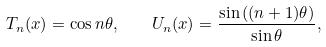<formula> <loc_0><loc_0><loc_500><loc_500>T _ { n } ( x ) = \cos n \theta , \quad U _ { n } ( x ) = \frac { \sin \left ( ( n + 1 ) \theta \right ) } { \sin \theta } ,</formula> 